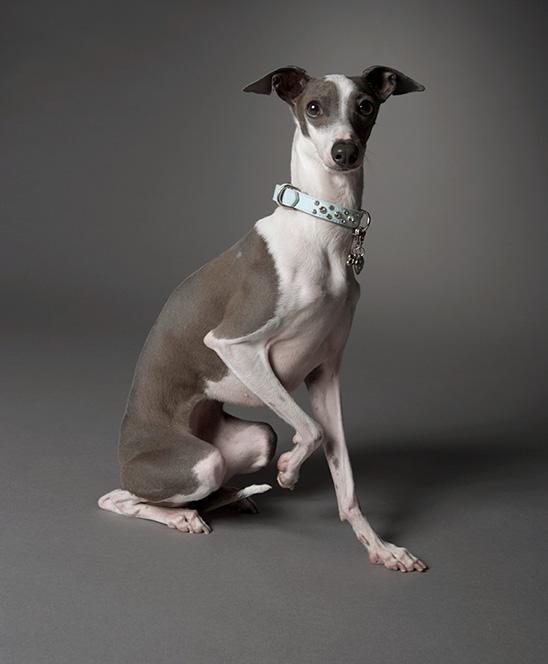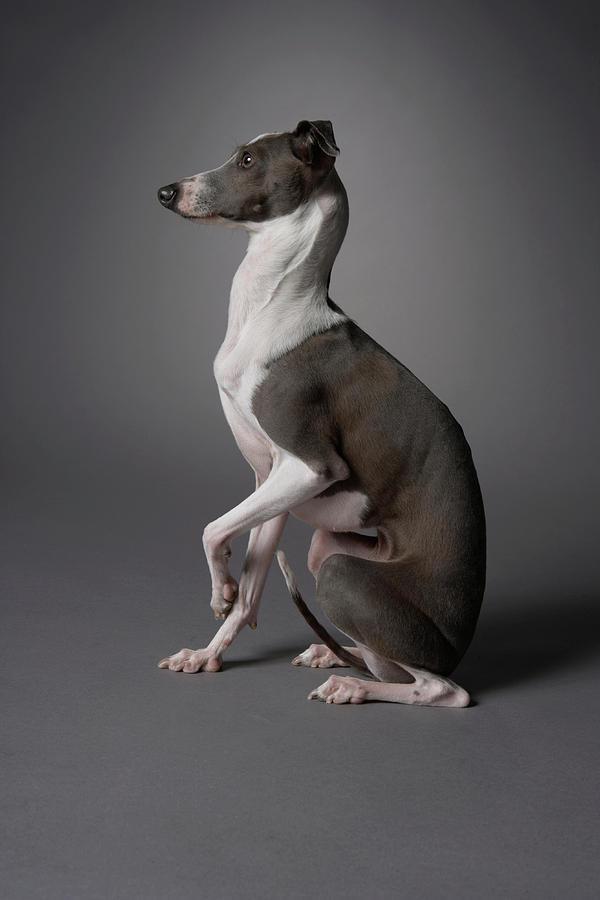The first image is the image on the left, the second image is the image on the right. Examine the images to the left and right. Is the description "An image contains a thin dark dog that is looking towards the right." accurate? Answer yes or no. No. The first image is the image on the left, the second image is the image on the right. For the images shown, is this caption "A dog with a collar is looking at the camera in the image on the left." true? Answer yes or no. Yes. 